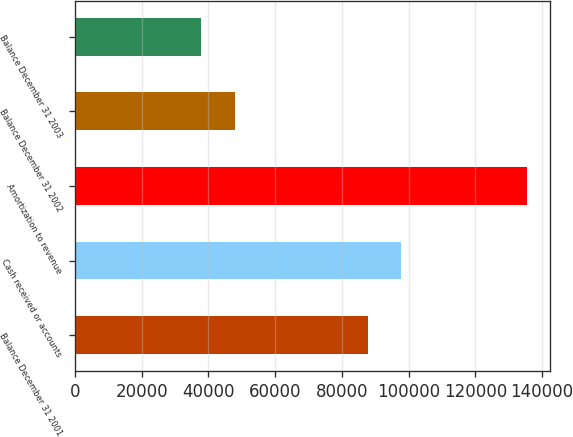Convert chart to OTSL. <chart><loc_0><loc_0><loc_500><loc_500><bar_chart><fcel>Balance December 31 2001<fcel>Cash received or accounts<fcel>Amortization to revenue<fcel>Balance December 31 2002<fcel>Balance December 31 2003<nl><fcel>87978<fcel>97740.2<fcel>135466<fcel>47916<fcel>37844<nl></chart> 